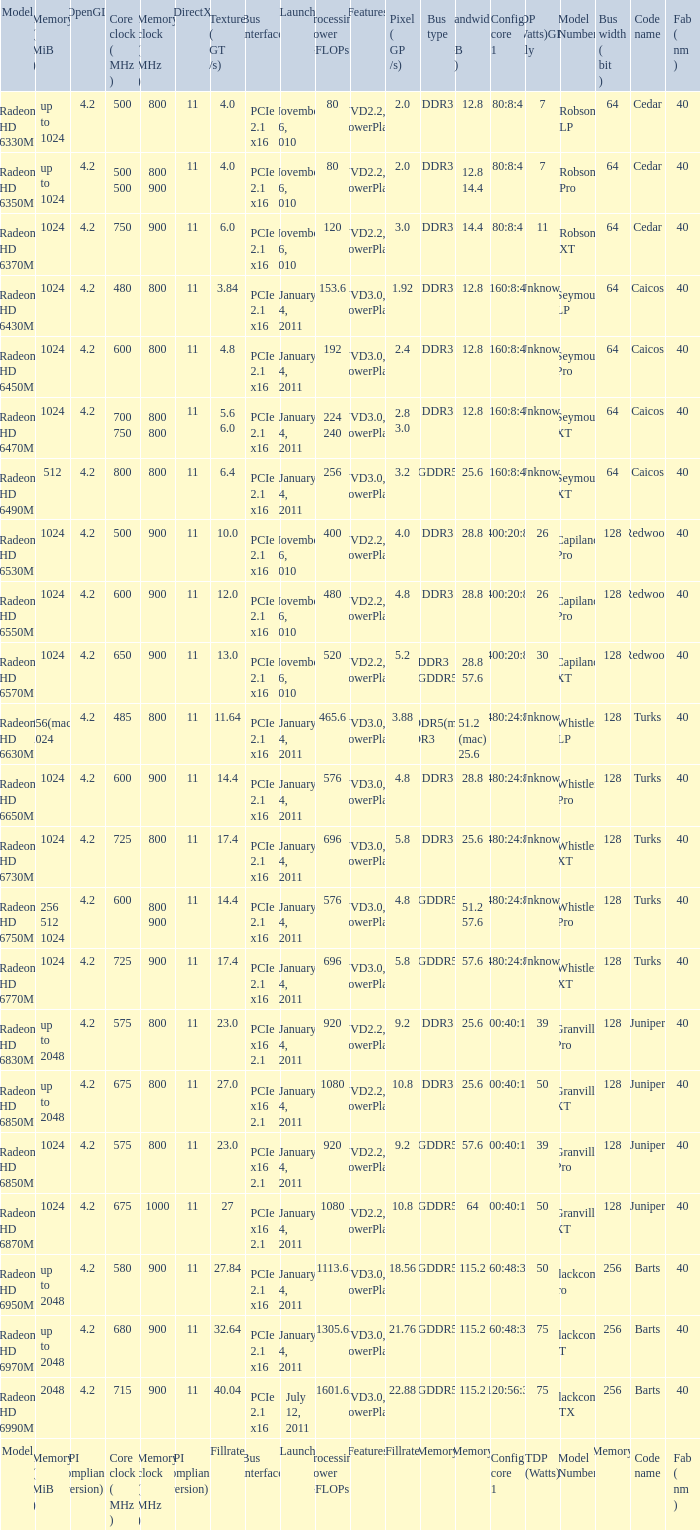What is every bus type for the texture of fillrate? Memory. 